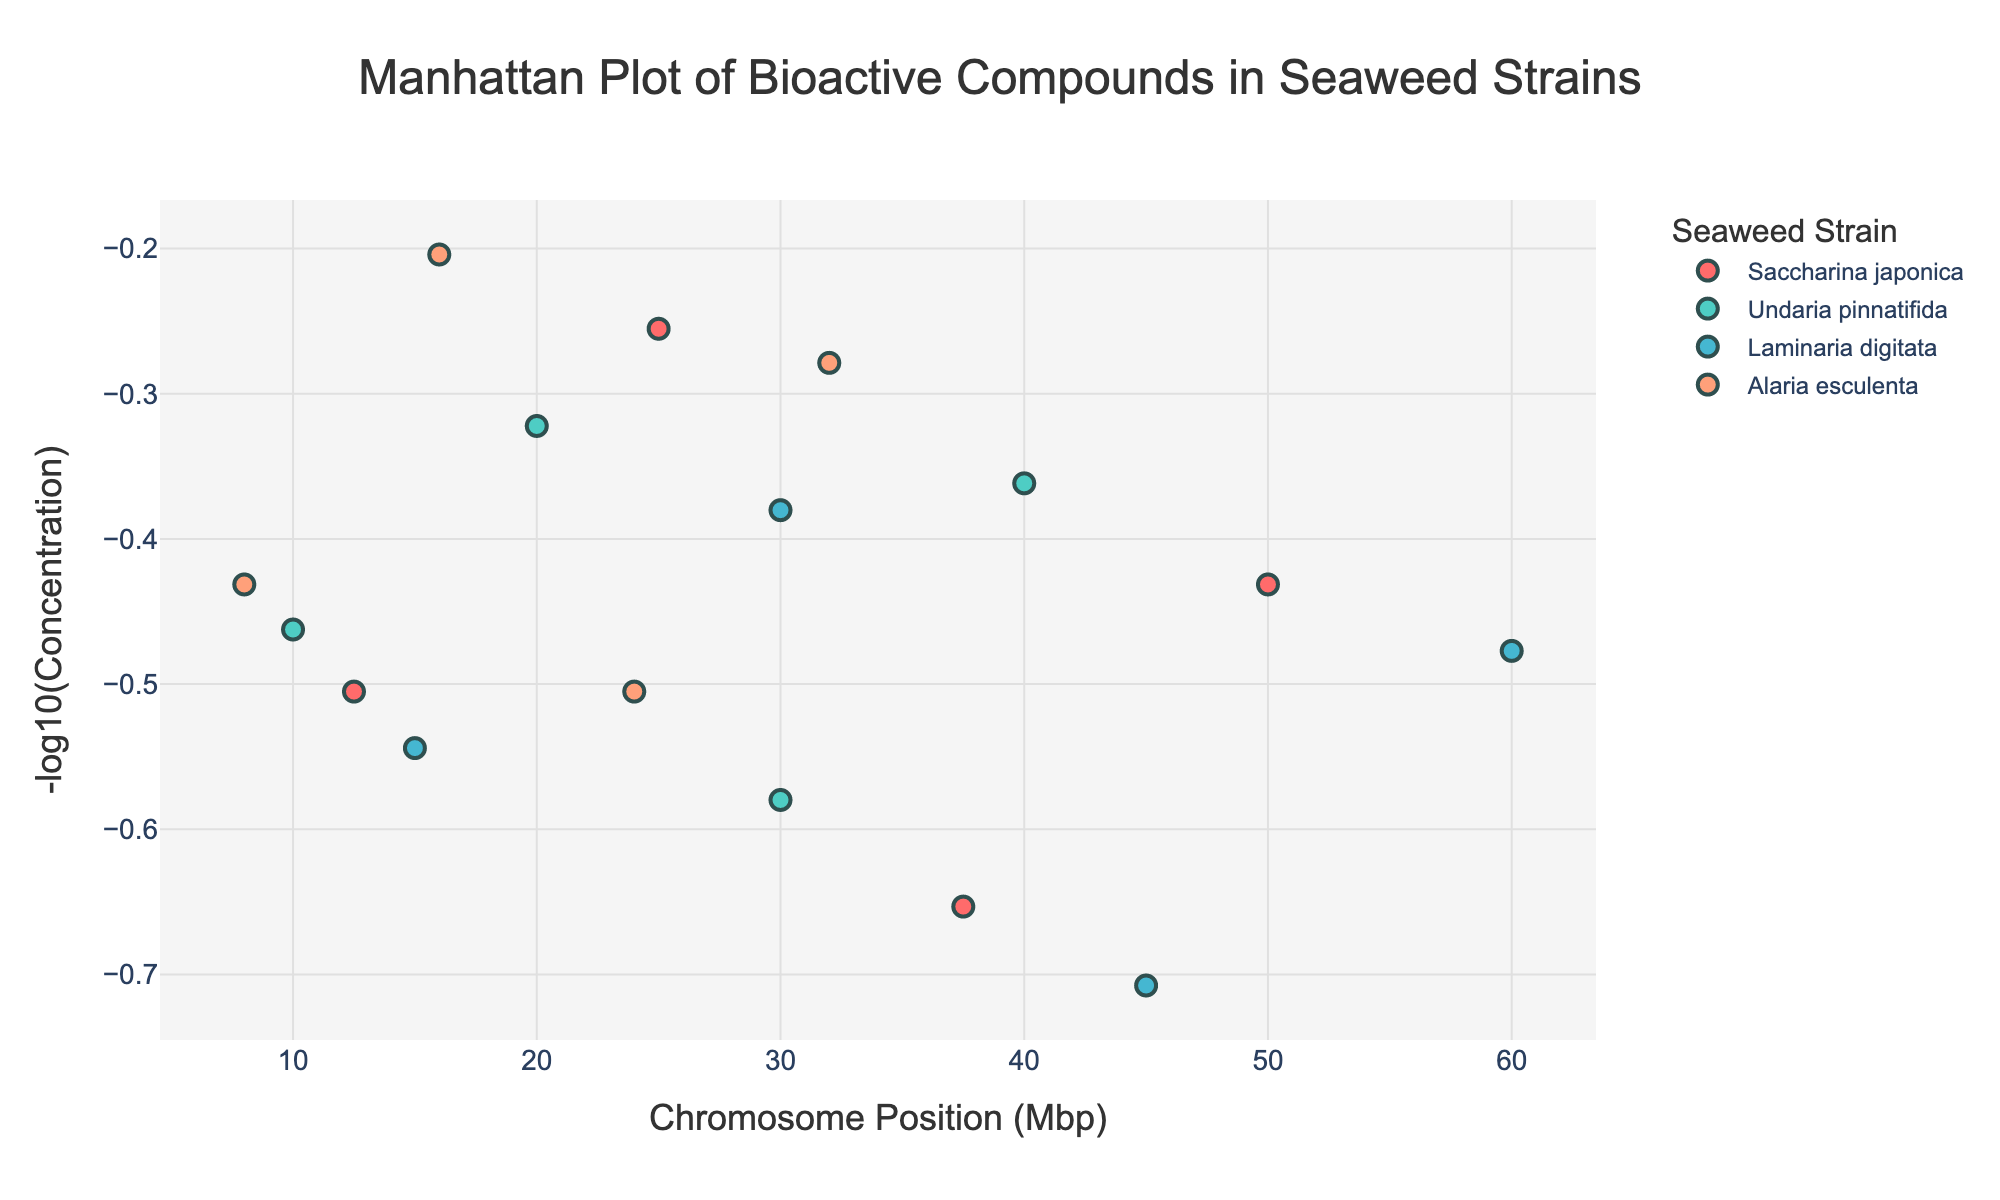What is the title of the figure? The title of the figure is prominently displayed at the top. It reads "Manhattan Plot of Bioactive Compounds in Seaweed Strains."
Answer: Manhattan Plot of Bioactive Compounds in Seaweed Strains What are the units used for the x-axis? The x-axis represents Chromosome Position, and the units are in Megabase pairs (Mbp). This is indicated in the x-axis title.
Answer: Megabase pairs (Mbp) Which strain has the highest -log10(Concentration) value? The highest -log10(Concentration) value can be identified by looking at the highest data point on the y-axis. In this case, it belongs to "Laminaria digitata" with a value of approximately 0.31 at position 45 Mbp.
Answer: Laminaria digitata How many strains are represented in the figure? The legend on the right-hand side of the figure lists the strains, which are marked with different colors. There are four strains: Saccharina japonica, Undaria pinnatifida, Laminaria digitata, and Alaria esculenta.
Answer: Four What is the -log10(Concentration) value of Fucoxanthin in Saccharina japonica? To find this value, locate the data point for Fucoxanthin in Saccharina japonica at position 12.5 Mbp on the x-axis. The y-value or -log10(Concentration) for this point is approximately 0.49.
Answer: 0.49 What is the range of Chromosome Positions (Mbp) for Undaria pinnatifida? The range can be identified by looking for the data points corresponding to Undaria pinnatifida (color-coded) and noting the minimum and maximum x-axis positions. The range is from roughly 10 Mbp to 40 Mbp.
Answer: 10 Mbp to 40 Mbp Compare the -log10(Concentration) values of Fucoidan between Undaria pinnatifida and Laminaria digitata. Which one is higher? To compare, locate the data points for Fucoidan in Undaria pinnatifida at 20 Mbp and in Laminaria digitata at 30 Mbp. The -log10(Concentration) values are approximately 0.68 for Laminaria digitata and 0.68 for Undaria pinnatifida, so they are equal.
Answer: Equal Which compound has the highest concentration overall? To determine this, we need to find the lowest -log10(Concentration) value since higher actual concentrations correspond to lower -log10 values. The lowest value on the y-axis is around 0.31 for Alginate in Laminaria digitata at 45 Mbp, indicating it has the highest concentration.
Answer: Alginate in Laminaria digitata What is the difference in -log10(Concentration) values of Laminarin between Saccharina japonica and Alaria esculenta? Find the data points for Laminarin in both strains: for Saccharina japonica at 50 Mbp (approximately 0.57) and for Alaria esculenta at 32 Mbp (approximately 0.72). The difference is 0.72 - 0.57 = 0.15.
Answer: 0.15 What is the compound with the highest -log10(Concentration) value in Alaria esculenta? Look for the highest y-value data point among the data points for Alaria esculenta (color-coded). The highest -log10(Concentration) value is approximately 0.80, corresponding to Laminarin at 32 Mbp.
Answer: Laminarin 